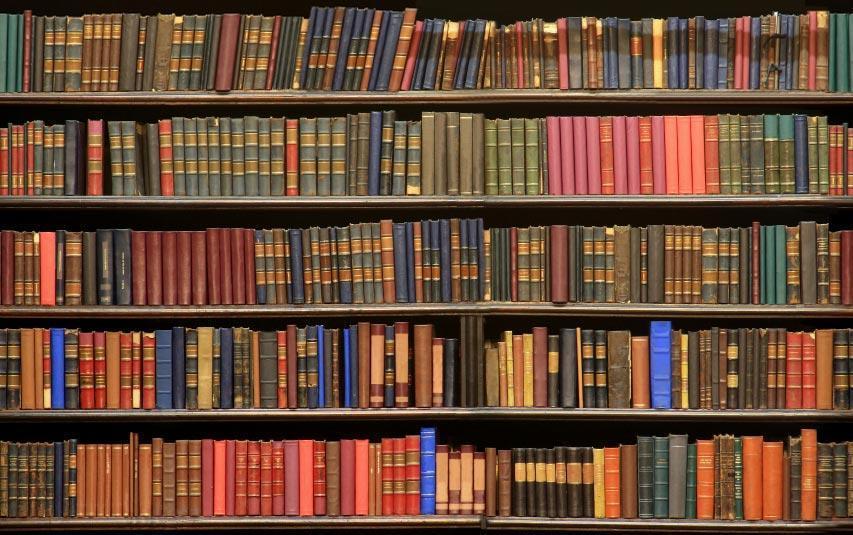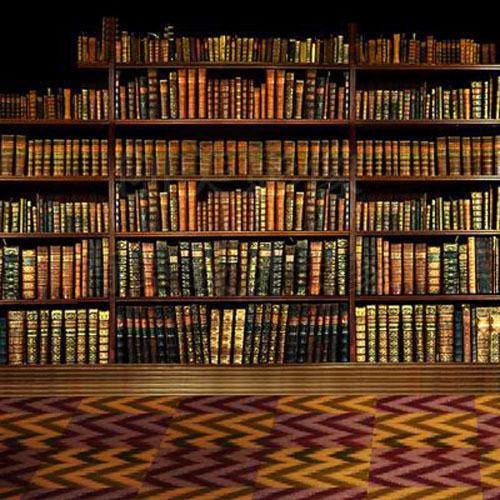The first image is the image on the left, the second image is the image on the right. Evaluate the accuracy of this statement regarding the images: "There are at least 13 books that are red, blue or white sitting on a single unseen shelve.". Is it true? Answer yes or no. No. The first image is the image on the left, the second image is the image on the right. Considering the images on both sides, is "One image shows the spines of books lined upright in a row, and the other image shows books stacked mostly upright on shelves, with some books stacked on their sides." valid? Answer yes or no. No. 